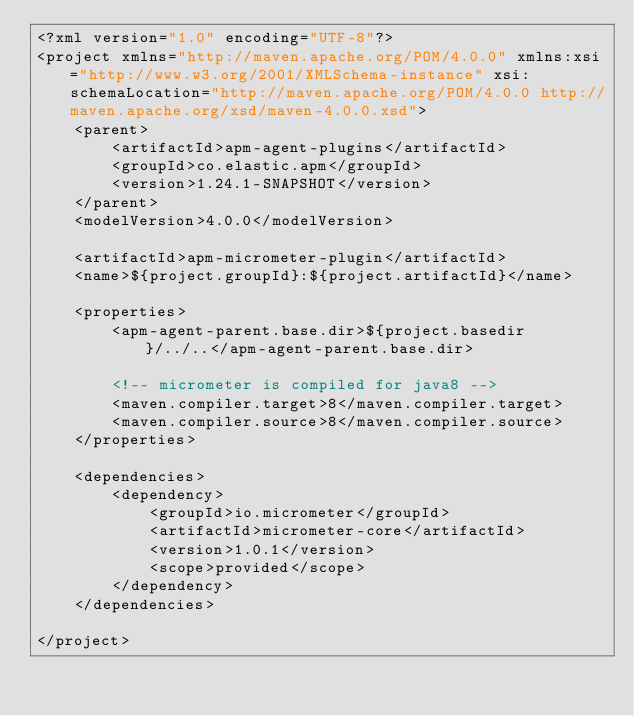<code> <loc_0><loc_0><loc_500><loc_500><_XML_><?xml version="1.0" encoding="UTF-8"?>
<project xmlns="http://maven.apache.org/POM/4.0.0" xmlns:xsi="http://www.w3.org/2001/XMLSchema-instance" xsi:schemaLocation="http://maven.apache.org/POM/4.0.0 http://maven.apache.org/xsd/maven-4.0.0.xsd">
    <parent>
        <artifactId>apm-agent-plugins</artifactId>
        <groupId>co.elastic.apm</groupId>
        <version>1.24.1-SNAPSHOT</version>
    </parent>
    <modelVersion>4.0.0</modelVersion>

    <artifactId>apm-micrometer-plugin</artifactId>
    <name>${project.groupId}:${project.artifactId}</name>

    <properties>
        <apm-agent-parent.base.dir>${project.basedir}/../..</apm-agent-parent.base.dir>

        <!-- micrometer is compiled for java8 -->
        <maven.compiler.target>8</maven.compiler.target>
        <maven.compiler.source>8</maven.compiler.source>
    </properties>

    <dependencies>
        <dependency>
            <groupId>io.micrometer</groupId>
            <artifactId>micrometer-core</artifactId>
            <version>1.0.1</version>
            <scope>provided</scope>
        </dependency>
    </dependencies>

</project>
</code> 